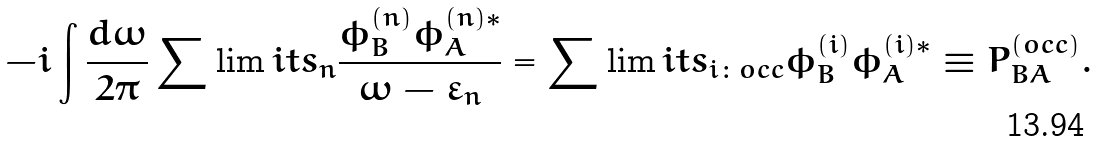<formula> <loc_0><loc_0><loc_500><loc_500>- i \int \frac { d \omega } { 2 \pi } \sum \lim i t s _ { n } \frac { \phi _ { B } ^ { ( n ) } \phi _ { A } ^ { ( n ) \ast } } { \omega - \varepsilon _ { n } } = \sum \lim i t s _ { i \colon o c c } \phi _ { B } ^ { ( i ) } \phi _ { A } ^ { ( i ) \ast } \equiv P _ { B A } ^ { ( o c c ) } .</formula> 